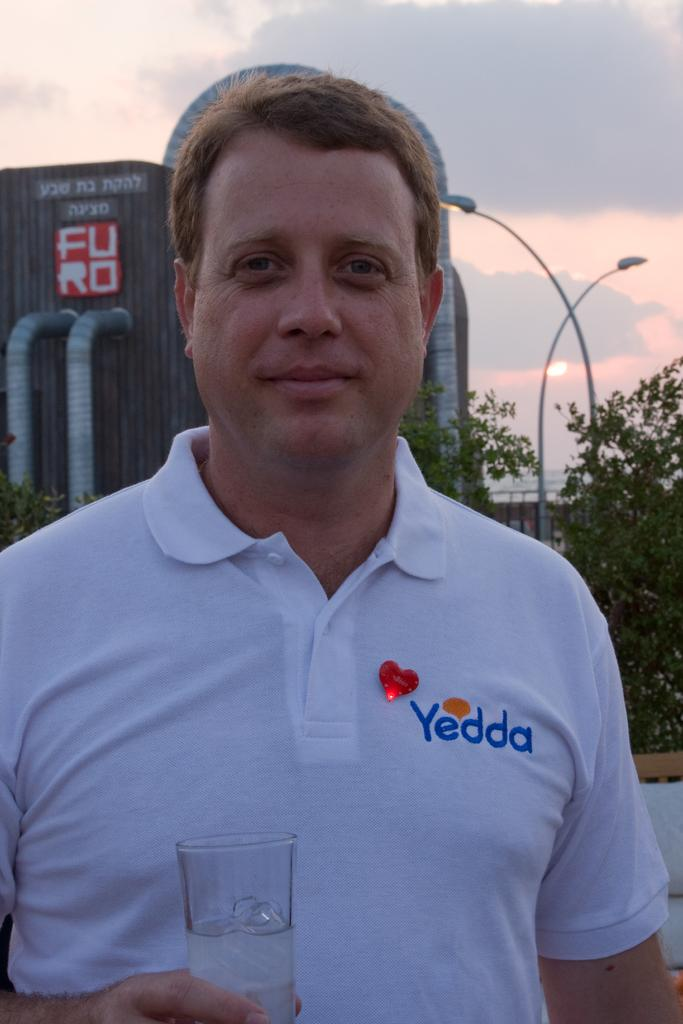What is the main subject of the image? There is a person in the image. What is the person holding in his hand? The person is holding a glass in his hand. What can be seen behind the person? There are trees, buildings, and light poles in the background. What is visible at the top of the image? There are clouds visible at the top of the image. Can you tell me the color of the vein on the person's leg in the image? There is no visible vein or leg mentioned in the provided facts, so we cannot determine the color of a vein on the person's leg. 